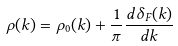<formula> <loc_0><loc_0><loc_500><loc_500>\rho ( k ) = \rho _ { 0 } ( k ) + \frac { 1 } { \pi } \frac { d \delta _ { F } ( k ) } { d k }</formula> 